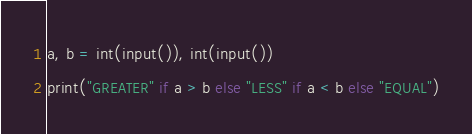Convert code to text. <code><loc_0><loc_0><loc_500><loc_500><_Python_>a, b = int(input()), int(input())
print("GREATER" if a > b else "LESS" if a < b else "EQUAL")</code> 